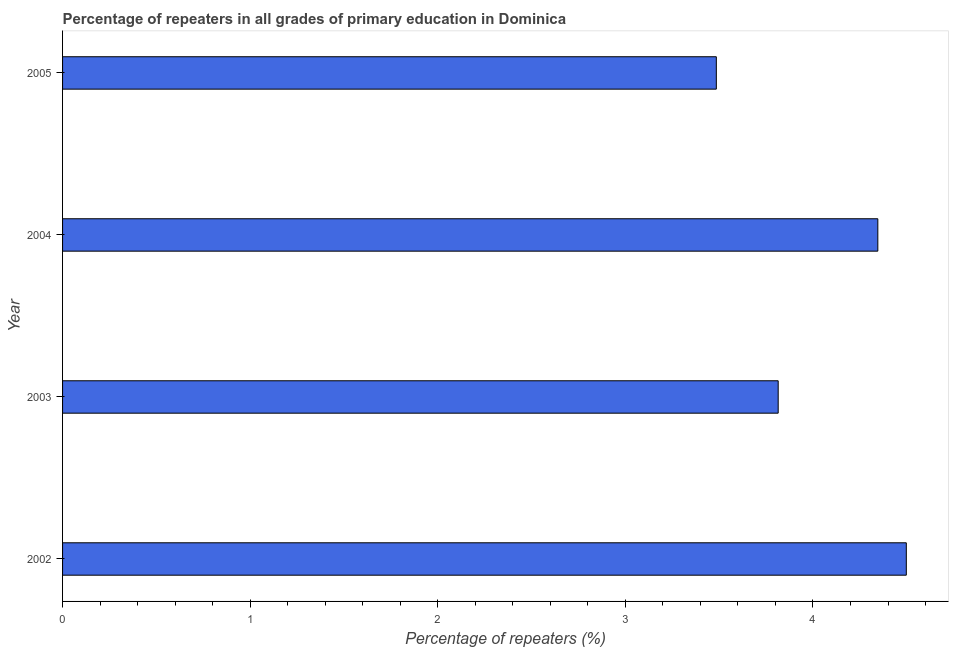Does the graph contain any zero values?
Ensure brevity in your answer.  No. Does the graph contain grids?
Your answer should be compact. No. What is the title of the graph?
Provide a succinct answer. Percentage of repeaters in all grades of primary education in Dominica. What is the label or title of the X-axis?
Make the answer very short. Percentage of repeaters (%). What is the label or title of the Y-axis?
Offer a terse response. Year. What is the percentage of repeaters in primary education in 2003?
Your answer should be compact. 3.81. Across all years, what is the maximum percentage of repeaters in primary education?
Your answer should be very brief. 4.5. Across all years, what is the minimum percentage of repeaters in primary education?
Offer a terse response. 3.48. In which year was the percentage of repeaters in primary education maximum?
Keep it short and to the point. 2002. What is the sum of the percentage of repeaters in primary education?
Provide a short and direct response. 16.14. What is the difference between the percentage of repeaters in primary education in 2003 and 2004?
Your response must be concise. -0.53. What is the average percentage of repeaters in primary education per year?
Provide a succinct answer. 4.04. What is the median percentage of repeaters in primary education?
Provide a short and direct response. 4.08. Do a majority of the years between 2004 and 2005 (inclusive) have percentage of repeaters in primary education greater than 4 %?
Keep it short and to the point. No. What is the ratio of the percentage of repeaters in primary education in 2002 to that in 2005?
Give a very brief answer. 1.29. What is the difference between the highest and the second highest percentage of repeaters in primary education?
Offer a terse response. 0.15. Is the sum of the percentage of repeaters in primary education in 2002 and 2003 greater than the maximum percentage of repeaters in primary education across all years?
Your response must be concise. Yes. In how many years, is the percentage of repeaters in primary education greater than the average percentage of repeaters in primary education taken over all years?
Your answer should be very brief. 2. Are all the bars in the graph horizontal?
Keep it short and to the point. Yes. How many years are there in the graph?
Provide a succinct answer. 4. Are the values on the major ticks of X-axis written in scientific E-notation?
Your answer should be very brief. No. What is the Percentage of repeaters (%) of 2002?
Your answer should be compact. 4.5. What is the Percentage of repeaters (%) in 2003?
Make the answer very short. 3.81. What is the Percentage of repeaters (%) of 2004?
Offer a terse response. 4.35. What is the Percentage of repeaters (%) of 2005?
Your answer should be very brief. 3.48. What is the difference between the Percentage of repeaters (%) in 2002 and 2003?
Provide a succinct answer. 0.68. What is the difference between the Percentage of repeaters (%) in 2002 and 2004?
Offer a terse response. 0.15. What is the difference between the Percentage of repeaters (%) in 2002 and 2005?
Give a very brief answer. 1.01. What is the difference between the Percentage of repeaters (%) in 2003 and 2004?
Provide a short and direct response. -0.53. What is the difference between the Percentage of repeaters (%) in 2003 and 2005?
Offer a terse response. 0.33. What is the difference between the Percentage of repeaters (%) in 2004 and 2005?
Offer a very short reply. 0.86. What is the ratio of the Percentage of repeaters (%) in 2002 to that in 2003?
Keep it short and to the point. 1.18. What is the ratio of the Percentage of repeaters (%) in 2002 to that in 2004?
Provide a succinct answer. 1.03. What is the ratio of the Percentage of repeaters (%) in 2002 to that in 2005?
Keep it short and to the point. 1.29. What is the ratio of the Percentage of repeaters (%) in 2003 to that in 2004?
Your answer should be compact. 0.88. What is the ratio of the Percentage of repeaters (%) in 2003 to that in 2005?
Ensure brevity in your answer.  1.09. What is the ratio of the Percentage of repeaters (%) in 2004 to that in 2005?
Your response must be concise. 1.25. 